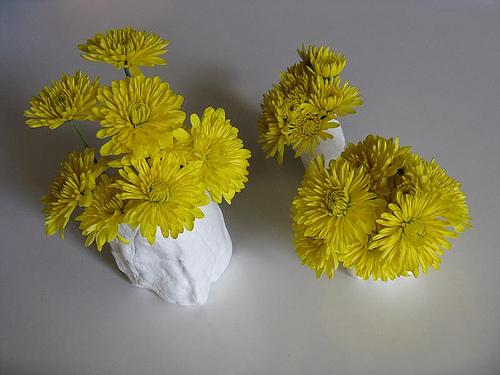Can you identify any special characteristics of the flowers' stems or petals? The flowers' stems are visible and their yellow petals are in various stages of blooming. What can you tell about the flowers in the image, besides their color? The flowers have yellow petals, they are blooming, and their stems are visible. Identify the primary elements in the picture and discuss their appearance. The image consists of several yellow flowers blooming, placed on a white table and arranged in white clay vases, accompanied by some shadows on the table. What are the general characteristics of the yellow flowers in the image, and what color are the objects they are placed in? The general characteristics of the yellow flowers include blooming petals and visible stems, and they are placed in white objects, which are clay vases. What is the significant aspect of the table, and what color is it? The significant aspect of the table is that it is the surface the vases and flowers are on, and it is white in color. Which objects are the main subject of the image, and what is their color? The main subject of the image is a bunch of yellow flowers on a table with white vases. Describe the composition of the image, focusing on the interaction between the flowers, the vases, and the table. The image shows a group of yellow flowers with blooming petals and visible stems, arranged in white clay vases, and placed on a white table, creating an aesthetically pleasing setup. In the image, what color are the flowers and the vase they are in? The flowers are yellow, and the vase they are in is white. Describe the object that the flowers are placed in within the image. The flowers are placed in white clay vases, which appear to be made out of clay. Provide a brief description of the overall scene depicted in the image. In the image, a bunch of yellow flowers are arranged in white clay vases and placed on a white table, with visible shadows and petals on the plants. 